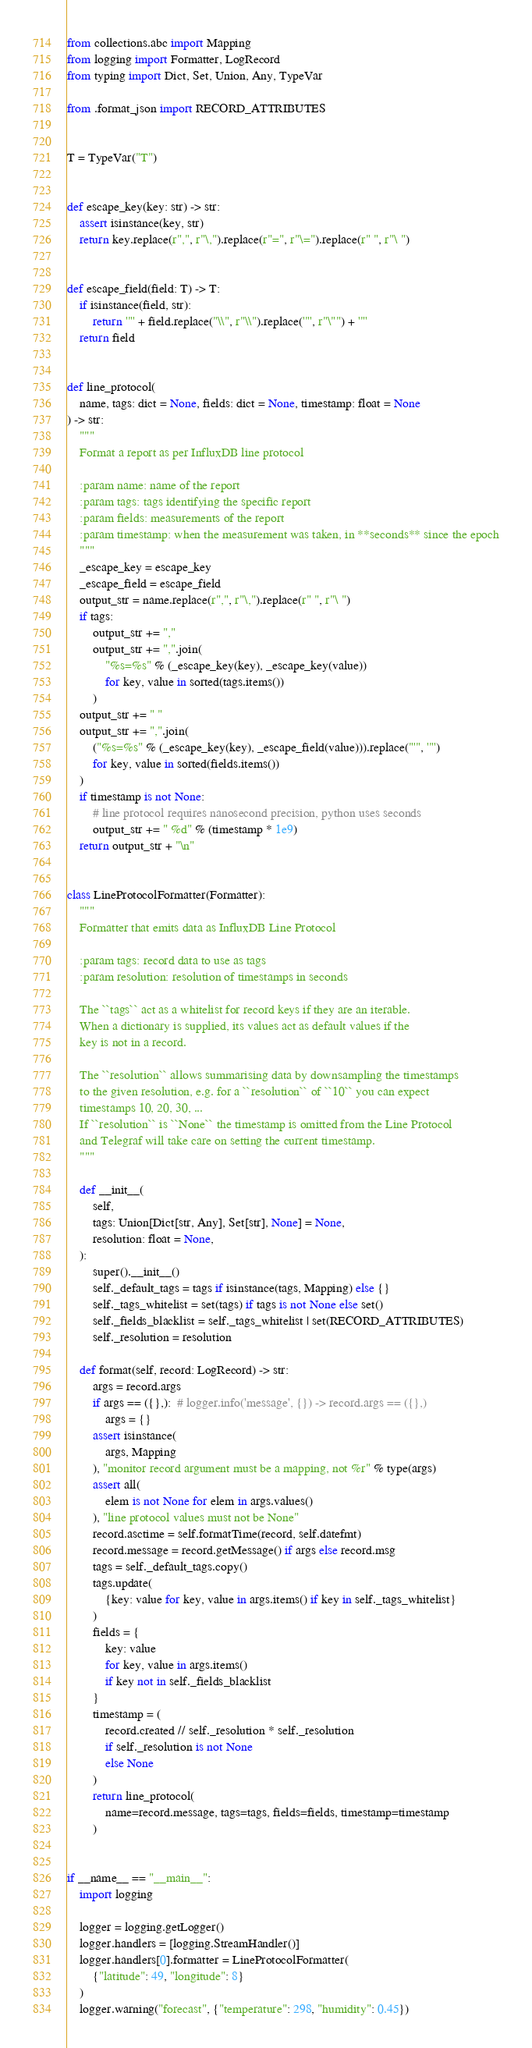<code> <loc_0><loc_0><loc_500><loc_500><_Python_>from collections.abc import Mapping
from logging import Formatter, LogRecord
from typing import Dict, Set, Union, Any, TypeVar

from .format_json import RECORD_ATTRIBUTES


T = TypeVar("T")


def escape_key(key: str) -> str:
    assert isinstance(key, str)
    return key.replace(r",", r"\,").replace(r"=", r"\=").replace(r" ", r"\ ")


def escape_field(field: T) -> T:
    if isinstance(field, str):
        return '"' + field.replace("\\", r"\\").replace('"', r"\"") + '"'
    return field


def line_protocol(
    name, tags: dict = None, fields: dict = None, timestamp: float = None
) -> str:
    """
    Format a report as per InfluxDB line protocol

    :param name: name of the report
    :param tags: tags identifying the specific report
    :param fields: measurements of the report
    :param timestamp: when the measurement was taken, in **seconds** since the epoch
    """
    _escape_key = escape_key
    _escape_field = escape_field
    output_str = name.replace(r",", r"\,").replace(r" ", r"\ ")
    if tags:
        output_str += ","
        output_str += ",".join(
            "%s=%s" % (_escape_key(key), _escape_key(value))
            for key, value in sorted(tags.items())
        )
    output_str += " "
    output_str += ",".join(
        ("%s=%s" % (_escape_key(key), _escape_field(value))).replace("'", '"')
        for key, value in sorted(fields.items())
    )
    if timestamp is not None:
        # line protocol requires nanosecond precision, python uses seconds
        output_str += " %d" % (timestamp * 1e9)
    return output_str + "\n"


class LineProtocolFormatter(Formatter):
    """
    Formatter that emits data as InfluxDB Line Protocol

    :param tags: record data to use as tags
    :param resolution: resolution of timestamps in seconds

    The ``tags`` act as a whitelist for record keys if they are an iterable.
    When a dictionary is supplied, its values act as default values if the
    key is not in a record.

    The ``resolution`` allows summarising data by downsampling the timestamps
    to the given resolution, e.g. for a ``resolution`` of ``10`` you can expect
    timestamps 10, 20, 30, ...
    If ``resolution`` is ``None`` the timestamp is omitted from the Line Protocol
    and Telegraf will take care on setting the current timestamp.
    """

    def __init__(
        self,
        tags: Union[Dict[str, Any], Set[str], None] = None,
        resolution: float = None,
    ):
        super().__init__()
        self._default_tags = tags if isinstance(tags, Mapping) else {}
        self._tags_whitelist = set(tags) if tags is not None else set()
        self._fields_blacklist = self._tags_whitelist | set(RECORD_ATTRIBUTES)
        self._resolution = resolution

    def format(self, record: LogRecord) -> str:
        args = record.args
        if args == ({},):  # logger.info('message', {}) -> record.args == ({},)
            args = {}
        assert isinstance(
            args, Mapping
        ), "monitor record argument must be a mapping, not %r" % type(args)
        assert all(
            elem is not None for elem in args.values()
        ), "line protocol values must not be None"
        record.asctime = self.formatTime(record, self.datefmt)
        record.message = record.getMessage() if args else record.msg
        tags = self._default_tags.copy()
        tags.update(
            {key: value for key, value in args.items() if key in self._tags_whitelist}
        )
        fields = {
            key: value
            for key, value in args.items()
            if key not in self._fields_blacklist
        }
        timestamp = (
            record.created // self._resolution * self._resolution
            if self._resolution is not None
            else None
        )
        return line_protocol(
            name=record.message, tags=tags, fields=fields, timestamp=timestamp
        )


if __name__ == "__main__":
    import logging

    logger = logging.getLogger()
    logger.handlers = [logging.StreamHandler()]
    logger.handlers[0].formatter = LineProtocolFormatter(
        {"latitude": 49, "longitude": 8}
    )
    logger.warning("forecast", {"temperature": 298, "humidity": 0.45})
</code> 